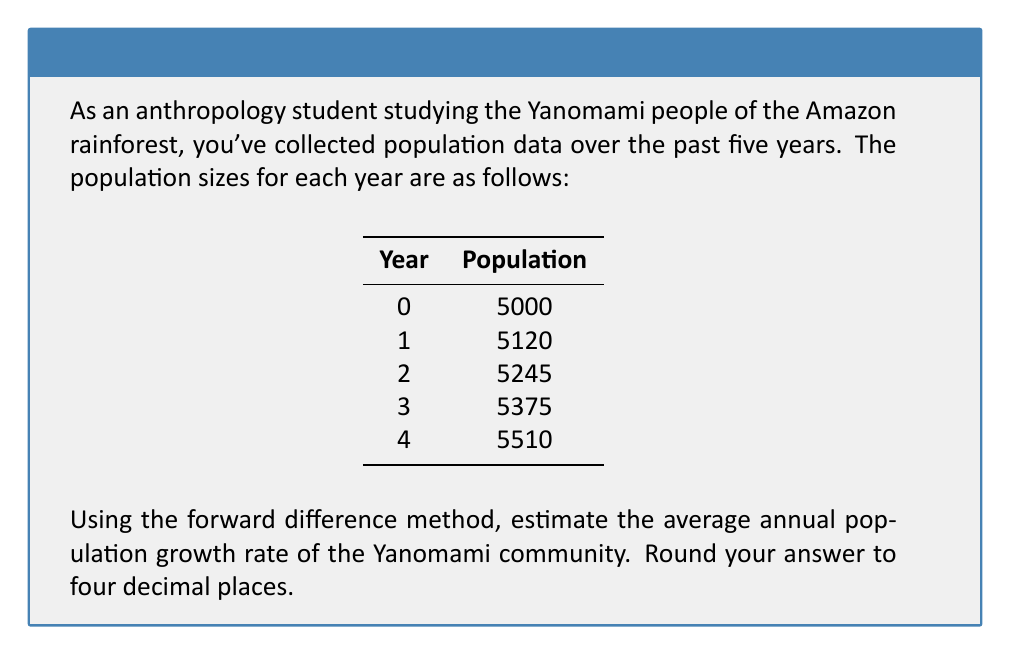Can you solve this math problem? To estimate the average annual population growth rate using the forward difference method, we'll follow these steps:

1) The forward difference formula for population growth rate is:

   $$r = \frac{P_{n+1} - P_n}{P_n}$$

   where $r$ is the growth rate, $P_n$ is the population at time $n$, and $P_{n+1}$ is the population at time $n+1$.

2) Calculate the growth rate for each year:

   Year 0 to 1: $r_1 = \frac{5120 - 5000}{5000} = 0.0240$
   Year 1 to 2: $r_2 = \frac{5245 - 5120}{5120} = 0.0244$
   Year 2 to 3: $r_3 = \frac{5375 - 5245}{5245} = 0.0248$
   Year 3 to 4: $r_4 = \frac{5510 - 5375}{5375} = 0.0251$

3) Calculate the average of these growth rates:

   $$\bar{r} = \frac{r_1 + r_2 + r_3 + r_4}{4}$$
   $$\bar{r} = \frac{0.0240 + 0.0244 + 0.0248 + 0.0251}{4} = 0.024575$$

4) Round to four decimal places:

   $\bar{r} \approx 0.0246$

Thus, the estimated average annual population growth rate is 0.0246 or 2.46%.
Answer: 0.0246 